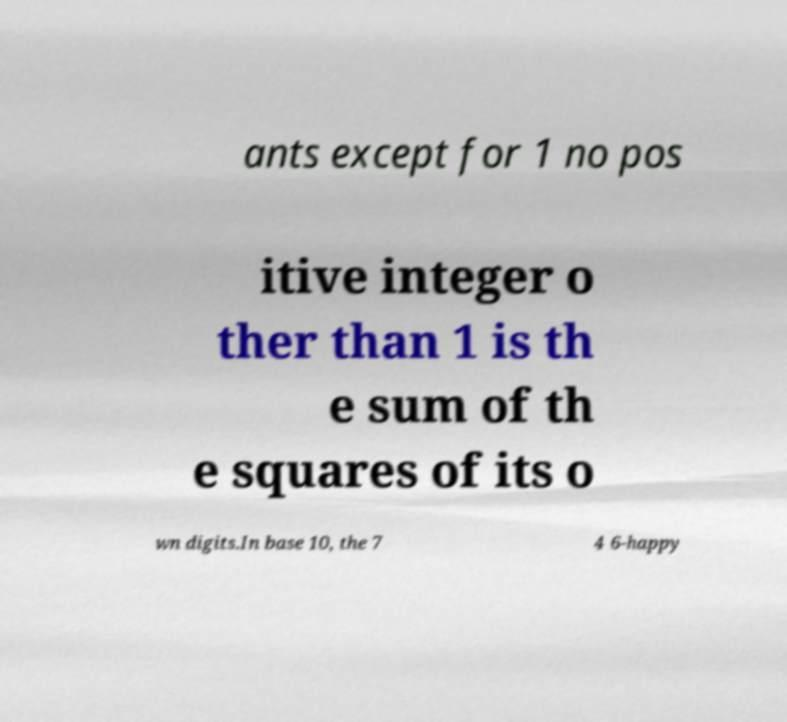Please read and relay the text visible in this image. What does it say? ants except for 1 no pos itive integer o ther than 1 is th e sum of th e squares of its o wn digits.In base 10, the 7 4 6-happy 